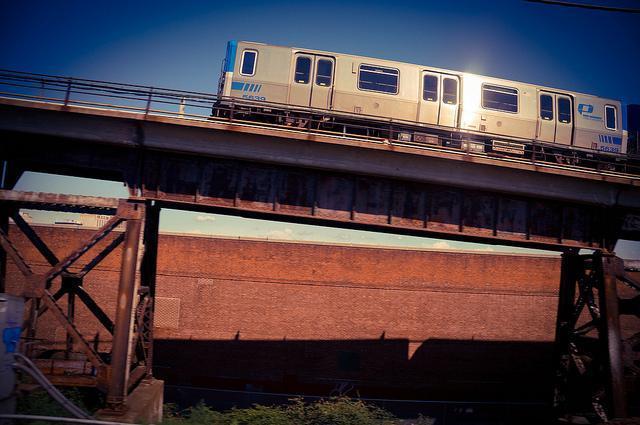How many windows can be seen on the train car?
Give a very brief answer. 10. How many trains are in the picture?
Give a very brief answer. 1. How many people are wearing a black shirt?
Give a very brief answer. 0. 